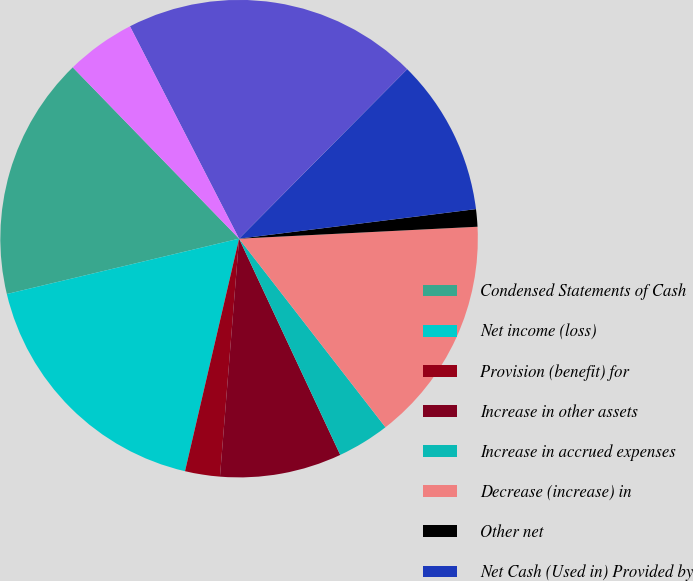<chart> <loc_0><loc_0><loc_500><loc_500><pie_chart><fcel>Condensed Statements of Cash<fcel>Net income (loss)<fcel>Provision (benefit) for<fcel>Increase in other assets<fcel>Increase in accrued expenses<fcel>Decrease (increase) in<fcel>Other net<fcel>Net Cash (Used in) Provided by<fcel>Increase in short-term<fcel>(Increase) decrease in loans<nl><fcel>16.46%<fcel>17.64%<fcel>2.36%<fcel>8.24%<fcel>3.54%<fcel>15.29%<fcel>1.18%<fcel>10.59%<fcel>19.99%<fcel>4.71%<nl></chart> 